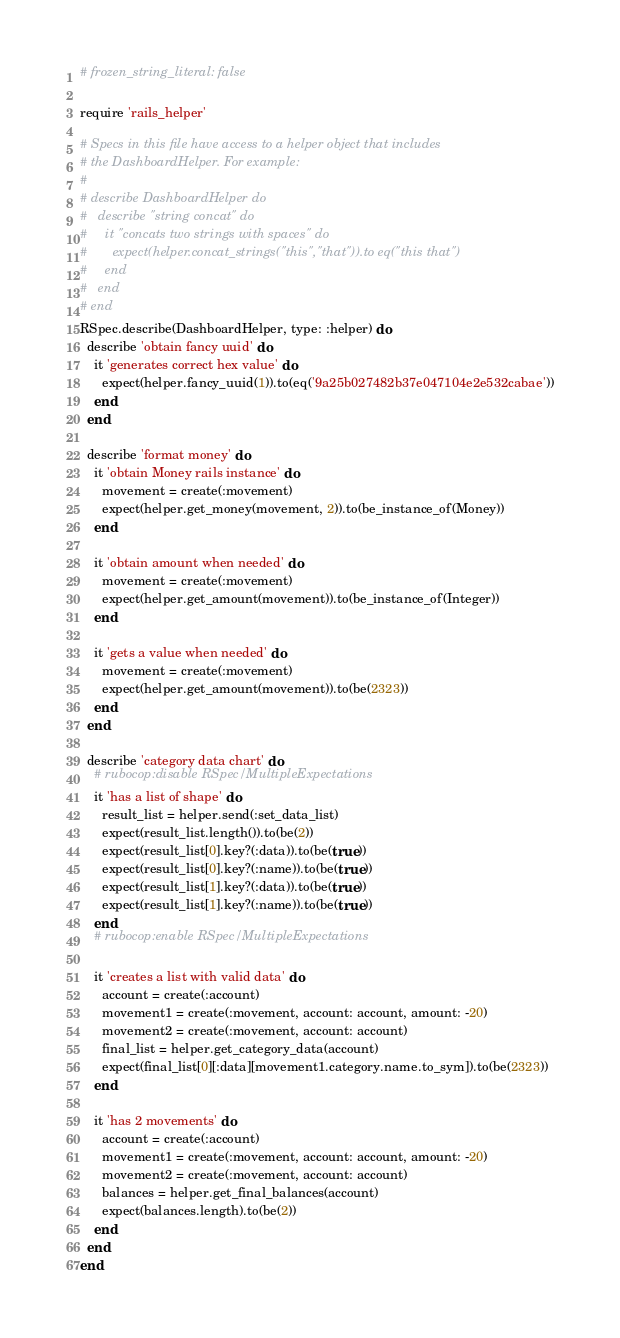Convert code to text. <code><loc_0><loc_0><loc_500><loc_500><_Ruby_># frozen_string_literal: false

require 'rails_helper'

# Specs in this file have access to a helper object that includes
# the DashboardHelper. For example:
#
# describe DashboardHelper do
#   describe "string concat" do
#     it "concats two strings with spaces" do
#       expect(helper.concat_strings("this","that")).to eq("this that")
#     end
#   end
# end
RSpec.describe(DashboardHelper, type: :helper) do
  describe 'obtain fancy uuid' do
    it 'generates correct hex value' do
      expect(helper.fancy_uuid(1)).to(eq('9a25b027482b37e047104e2e532cabae'))
    end
  end

  describe 'format money' do
    it 'obtain Money rails instance' do
      movement = create(:movement)
      expect(helper.get_money(movement, 2)).to(be_instance_of(Money))
    end

    it 'obtain amount when needed' do
      movement = create(:movement)
      expect(helper.get_amount(movement)).to(be_instance_of(Integer))
    end

    it 'gets a value when needed' do
      movement = create(:movement)
      expect(helper.get_amount(movement)).to(be(2323))
    end
  end

  describe 'category data chart' do
    # rubocop:disable RSpec/MultipleExpectations
    it 'has a list of shape' do
      result_list = helper.send(:set_data_list)
      expect(result_list.length()).to(be(2))
      expect(result_list[0].key?(:data)).to(be(true))
      expect(result_list[0].key?(:name)).to(be(true))
      expect(result_list[1].key?(:data)).to(be(true))
      expect(result_list[1].key?(:name)).to(be(true))
    end
    # rubocop:enable RSpec/MultipleExpectations

    it 'creates a list with valid data' do
      account = create(:account)
      movement1 = create(:movement, account: account, amount: -20)
      movement2 = create(:movement, account: account)
      final_list = helper.get_category_data(account)
      expect(final_list[0][:data][movement1.category.name.to_sym]).to(be(2323))
    end

    it 'has 2 movements' do
      account = create(:account)
      movement1 = create(:movement, account: account, amount: -20)
      movement2 = create(:movement, account: account)
      balances = helper.get_final_balances(account)
      expect(balances.length).to(be(2))
    end
  end
end
</code> 